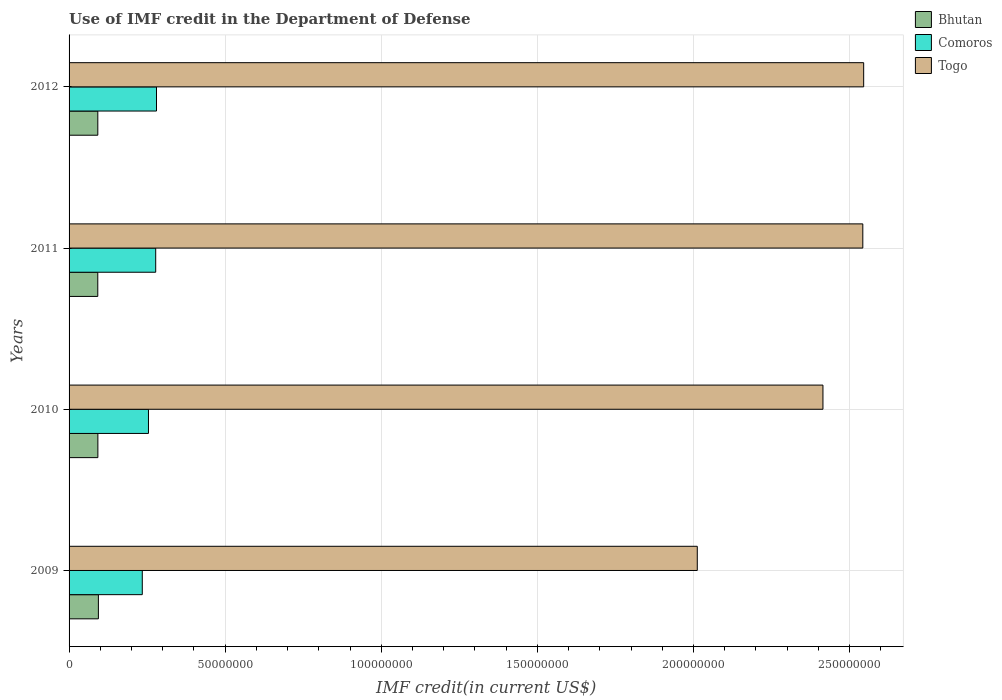Are the number of bars on each tick of the Y-axis equal?
Make the answer very short. Yes. How many bars are there on the 3rd tick from the top?
Your answer should be very brief. 3. How many bars are there on the 4th tick from the bottom?
Keep it short and to the point. 3. What is the IMF credit in the Department of Defense in Comoros in 2011?
Provide a succinct answer. 2.77e+07. Across all years, what is the maximum IMF credit in the Department of Defense in Bhutan?
Provide a short and direct response. 9.39e+06. Across all years, what is the minimum IMF credit in the Department of Defense in Bhutan?
Offer a terse response. 9.20e+06. In which year was the IMF credit in the Department of Defense in Togo minimum?
Make the answer very short. 2009. What is the total IMF credit in the Department of Defense in Togo in the graph?
Ensure brevity in your answer.  9.51e+08. What is the difference between the IMF credit in the Department of Defense in Comoros in 2009 and that in 2010?
Offer a terse response. -1.98e+06. What is the difference between the IMF credit in the Department of Defense in Togo in 2009 and the IMF credit in the Department of Defense in Bhutan in 2012?
Provide a short and direct response. 1.92e+08. What is the average IMF credit in the Department of Defense in Comoros per year?
Your answer should be very brief. 2.62e+07. In the year 2009, what is the difference between the IMF credit in the Department of Defense in Comoros and IMF credit in the Department of Defense in Bhutan?
Your answer should be compact. 1.41e+07. What is the ratio of the IMF credit in the Department of Defense in Togo in 2010 to that in 2012?
Offer a very short reply. 0.95. Is the IMF credit in the Department of Defense in Bhutan in 2009 less than that in 2012?
Give a very brief answer. No. Is the difference between the IMF credit in the Department of Defense in Comoros in 2009 and 2011 greater than the difference between the IMF credit in the Department of Defense in Bhutan in 2009 and 2011?
Your answer should be compact. No. What is the difference between the highest and the second highest IMF credit in the Department of Defense in Bhutan?
Provide a short and direct response. 1.66e+05. What is the difference between the highest and the lowest IMF credit in the Department of Defense in Togo?
Offer a very short reply. 5.33e+07. What does the 2nd bar from the top in 2009 represents?
Give a very brief answer. Comoros. What does the 1st bar from the bottom in 2012 represents?
Ensure brevity in your answer.  Bhutan. Is it the case that in every year, the sum of the IMF credit in the Department of Defense in Comoros and IMF credit in the Department of Defense in Togo is greater than the IMF credit in the Department of Defense in Bhutan?
Provide a succinct answer. Yes. Are all the bars in the graph horizontal?
Provide a succinct answer. Yes. How many years are there in the graph?
Ensure brevity in your answer.  4. What is the difference between two consecutive major ticks on the X-axis?
Give a very brief answer. 5.00e+07. Are the values on the major ticks of X-axis written in scientific E-notation?
Provide a short and direct response. No. Does the graph contain any zero values?
Keep it short and to the point. No. Does the graph contain grids?
Provide a succinct answer. Yes. Where does the legend appear in the graph?
Your response must be concise. Top right. What is the title of the graph?
Give a very brief answer. Use of IMF credit in the Department of Defense. Does "Belize" appear as one of the legend labels in the graph?
Your response must be concise. No. What is the label or title of the X-axis?
Keep it short and to the point. IMF credit(in current US$). What is the IMF credit(in current US$) in Bhutan in 2009?
Make the answer very short. 9.39e+06. What is the IMF credit(in current US$) of Comoros in 2009?
Offer a very short reply. 2.34e+07. What is the IMF credit(in current US$) of Togo in 2009?
Keep it short and to the point. 2.01e+08. What is the IMF credit(in current US$) in Bhutan in 2010?
Provide a succinct answer. 9.22e+06. What is the IMF credit(in current US$) of Comoros in 2010?
Ensure brevity in your answer.  2.54e+07. What is the IMF credit(in current US$) of Togo in 2010?
Keep it short and to the point. 2.41e+08. What is the IMF credit(in current US$) of Bhutan in 2011?
Offer a terse response. 9.20e+06. What is the IMF credit(in current US$) in Comoros in 2011?
Provide a short and direct response. 2.77e+07. What is the IMF credit(in current US$) in Togo in 2011?
Ensure brevity in your answer.  2.54e+08. What is the IMF credit(in current US$) of Bhutan in 2012?
Your answer should be very brief. 9.20e+06. What is the IMF credit(in current US$) in Comoros in 2012?
Ensure brevity in your answer.  2.80e+07. What is the IMF credit(in current US$) of Togo in 2012?
Make the answer very short. 2.54e+08. Across all years, what is the maximum IMF credit(in current US$) in Bhutan?
Provide a succinct answer. 9.39e+06. Across all years, what is the maximum IMF credit(in current US$) of Comoros?
Your response must be concise. 2.80e+07. Across all years, what is the maximum IMF credit(in current US$) in Togo?
Ensure brevity in your answer.  2.54e+08. Across all years, what is the minimum IMF credit(in current US$) of Bhutan?
Provide a short and direct response. 9.20e+06. Across all years, what is the minimum IMF credit(in current US$) in Comoros?
Provide a succinct answer. 2.34e+07. Across all years, what is the minimum IMF credit(in current US$) in Togo?
Keep it short and to the point. 2.01e+08. What is the total IMF credit(in current US$) of Bhutan in the graph?
Keep it short and to the point. 3.70e+07. What is the total IMF credit(in current US$) of Comoros in the graph?
Provide a succinct answer. 1.05e+08. What is the total IMF credit(in current US$) in Togo in the graph?
Ensure brevity in your answer.  9.51e+08. What is the difference between the IMF credit(in current US$) of Bhutan in 2009 and that in 2010?
Keep it short and to the point. 1.66e+05. What is the difference between the IMF credit(in current US$) in Comoros in 2009 and that in 2010?
Provide a short and direct response. -1.98e+06. What is the difference between the IMF credit(in current US$) in Togo in 2009 and that in 2010?
Your answer should be very brief. -4.03e+07. What is the difference between the IMF credit(in current US$) in Bhutan in 2009 and that in 2011?
Your answer should be compact. 1.95e+05. What is the difference between the IMF credit(in current US$) of Comoros in 2009 and that in 2011?
Ensure brevity in your answer.  -4.30e+06. What is the difference between the IMF credit(in current US$) in Togo in 2009 and that in 2011?
Offer a very short reply. -5.30e+07. What is the difference between the IMF credit(in current US$) in Bhutan in 2009 and that in 2012?
Give a very brief answer. 1.85e+05. What is the difference between the IMF credit(in current US$) of Comoros in 2009 and that in 2012?
Offer a terse response. -4.55e+06. What is the difference between the IMF credit(in current US$) in Togo in 2009 and that in 2012?
Your answer should be very brief. -5.33e+07. What is the difference between the IMF credit(in current US$) of Bhutan in 2010 and that in 2011?
Your answer should be compact. 2.90e+04. What is the difference between the IMF credit(in current US$) in Comoros in 2010 and that in 2011?
Your response must be concise. -2.31e+06. What is the difference between the IMF credit(in current US$) in Togo in 2010 and that in 2011?
Your answer should be compact. -1.28e+07. What is the difference between the IMF credit(in current US$) of Bhutan in 2010 and that in 2012?
Make the answer very short. 1.90e+04. What is the difference between the IMF credit(in current US$) of Comoros in 2010 and that in 2012?
Ensure brevity in your answer.  -2.57e+06. What is the difference between the IMF credit(in current US$) in Togo in 2010 and that in 2012?
Your answer should be compact. -1.30e+07. What is the difference between the IMF credit(in current US$) in Comoros in 2011 and that in 2012?
Provide a short and direct response. -2.56e+05. What is the difference between the IMF credit(in current US$) in Togo in 2011 and that in 2012?
Provide a short and direct response. -2.74e+05. What is the difference between the IMF credit(in current US$) of Bhutan in 2009 and the IMF credit(in current US$) of Comoros in 2010?
Provide a succinct answer. -1.60e+07. What is the difference between the IMF credit(in current US$) in Bhutan in 2009 and the IMF credit(in current US$) in Togo in 2010?
Your answer should be compact. -2.32e+08. What is the difference between the IMF credit(in current US$) of Comoros in 2009 and the IMF credit(in current US$) of Togo in 2010?
Offer a terse response. -2.18e+08. What is the difference between the IMF credit(in current US$) of Bhutan in 2009 and the IMF credit(in current US$) of Comoros in 2011?
Offer a terse response. -1.84e+07. What is the difference between the IMF credit(in current US$) in Bhutan in 2009 and the IMF credit(in current US$) in Togo in 2011?
Offer a very short reply. -2.45e+08. What is the difference between the IMF credit(in current US$) of Comoros in 2009 and the IMF credit(in current US$) of Togo in 2011?
Provide a succinct answer. -2.31e+08. What is the difference between the IMF credit(in current US$) of Bhutan in 2009 and the IMF credit(in current US$) of Comoros in 2012?
Offer a terse response. -1.86e+07. What is the difference between the IMF credit(in current US$) of Bhutan in 2009 and the IMF credit(in current US$) of Togo in 2012?
Give a very brief answer. -2.45e+08. What is the difference between the IMF credit(in current US$) of Comoros in 2009 and the IMF credit(in current US$) of Togo in 2012?
Your answer should be compact. -2.31e+08. What is the difference between the IMF credit(in current US$) in Bhutan in 2010 and the IMF credit(in current US$) in Comoros in 2011?
Ensure brevity in your answer.  -1.85e+07. What is the difference between the IMF credit(in current US$) of Bhutan in 2010 and the IMF credit(in current US$) of Togo in 2011?
Offer a terse response. -2.45e+08. What is the difference between the IMF credit(in current US$) of Comoros in 2010 and the IMF credit(in current US$) of Togo in 2011?
Give a very brief answer. -2.29e+08. What is the difference between the IMF credit(in current US$) of Bhutan in 2010 and the IMF credit(in current US$) of Comoros in 2012?
Provide a succinct answer. -1.88e+07. What is the difference between the IMF credit(in current US$) in Bhutan in 2010 and the IMF credit(in current US$) in Togo in 2012?
Your response must be concise. -2.45e+08. What is the difference between the IMF credit(in current US$) in Comoros in 2010 and the IMF credit(in current US$) in Togo in 2012?
Provide a succinct answer. -2.29e+08. What is the difference between the IMF credit(in current US$) in Bhutan in 2011 and the IMF credit(in current US$) in Comoros in 2012?
Keep it short and to the point. -1.88e+07. What is the difference between the IMF credit(in current US$) in Bhutan in 2011 and the IMF credit(in current US$) in Togo in 2012?
Your answer should be compact. -2.45e+08. What is the difference between the IMF credit(in current US$) of Comoros in 2011 and the IMF credit(in current US$) of Togo in 2012?
Ensure brevity in your answer.  -2.27e+08. What is the average IMF credit(in current US$) of Bhutan per year?
Offer a very short reply. 9.25e+06. What is the average IMF credit(in current US$) in Comoros per year?
Offer a very short reply. 2.62e+07. What is the average IMF credit(in current US$) of Togo per year?
Make the answer very short. 2.38e+08. In the year 2009, what is the difference between the IMF credit(in current US$) in Bhutan and IMF credit(in current US$) in Comoros?
Your response must be concise. -1.41e+07. In the year 2009, what is the difference between the IMF credit(in current US$) of Bhutan and IMF credit(in current US$) of Togo?
Keep it short and to the point. -1.92e+08. In the year 2009, what is the difference between the IMF credit(in current US$) in Comoros and IMF credit(in current US$) in Togo?
Keep it short and to the point. -1.78e+08. In the year 2010, what is the difference between the IMF credit(in current US$) of Bhutan and IMF credit(in current US$) of Comoros?
Offer a very short reply. -1.62e+07. In the year 2010, what is the difference between the IMF credit(in current US$) in Bhutan and IMF credit(in current US$) in Togo?
Give a very brief answer. -2.32e+08. In the year 2010, what is the difference between the IMF credit(in current US$) in Comoros and IMF credit(in current US$) in Togo?
Your answer should be very brief. -2.16e+08. In the year 2011, what is the difference between the IMF credit(in current US$) of Bhutan and IMF credit(in current US$) of Comoros?
Provide a succinct answer. -1.85e+07. In the year 2011, what is the difference between the IMF credit(in current US$) of Bhutan and IMF credit(in current US$) of Togo?
Ensure brevity in your answer.  -2.45e+08. In the year 2011, what is the difference between the IMF credit(in current US$) in Comoros and IMF credit(in current US$) in Togo?
Keep it short and to the point. -2.26e+08. In the year 2012, what is the difference between the IMF credit(in current US$) in Bhutan and IMF credit(in current US$) in Comoros?
Keep it short and to the point. -1.88e+07. In the year 2012, what is the difference between the IMF credit(in current US$) of Bhutan and IMF credit(in current US$) of Togo?
Offer a terse response. -2.45e+08. In the year 2012, what is the difference between the IMF credit(in current US$) of Comoros and IMF credit(in current US$) of Togo?
Your answer should be very brief. -2.26e+08. What is the ratio of the IMF credit(in current US$) in Bhutan in 2009 to that in 2010?
Provide a short and direct response. 1.02. What is the ratio of the IMF credit(in current US$) of Comoros in 2009 to that in 2010?
Offer a very short reply. 0.92. What is the ratio of the IMF credit(in current US$) in Bhutan in 2009 to that in 2011?
Keep it short and to the point. 1.02. What is the ratio of the IMF credit(in current US$) in Comoros in 2009 to that in 2011?
Make the answer very short. 0.85. What is the ratio of the IMF credit(in current US$) of Togo in 2009 to that in 2011?
Make the answer very short. 0.79. What is the ratio of the IMF credit(in current US$) of Bhutan in 2009 to that in 2012?
Your response must be concise. 1.02. What is the ratio of the IMF credit(in current US$) of Comoros in 2009 to that in 2012?
Offer a very short reply. 0.84. What is the ratio of the IMF credit(in current US$) in Togo in 2009 to that in 2012?
Provide a succinct answer. 0.79. What is the ratio of the IMF credit(in current US$) of Comoros in 2010 to that in 2011?
Your answer should be compact. 0.92. What is the ratio of the IMF credit(in current US$) in Togo in 2010 to that in 2011?
Offer a terse response. 0.95. What is the ratio of the IMF credit(in current US$) of Comoros in 2010 to that in 2012?
Your answer should be compact. 0.91. What is the ratio of the IMF credit(in current US$) of Togo in 2010 to that in 2012?
Your answer should be very brief. 0.95. What is the ratio of the IMF credit(in current US$) of Bhutan in 2011 to that in 2012?
Offer a very short reply. 1. What is the ratio of the IMF credit(in current US$) of Comoros in 2011 to that in 2012?
Make the answer very short. 0.99. What is the difference between the highest and the second highest IMF credit(in current US$) of Bhutan?
Provide a succinct answer. 1.66e+05. What is the difference between the highest and the second highest IMF credit(in current US$) of Comoros?
Your answer should be very brief. 2.56e+05. What is the difference between the highest and the second highest IMF credit(in current US$) of Togo?
Ensure brevity in your answer.  2.74e+05. What is the difference between the highest and the lowest IMF credit(in current US$) in Bhutan?
Ensure brevity in your answer.  1.95e+05. What is the difference between the highest and the lowest IMF credit(in current US$) in Comoros?
Ensure brevity in your answer.  4.55e+06. What is the difference between the highest and the lowest IMF credit(in current US$) in Togo?
Provide a succinct answer. 5.33e+07. 